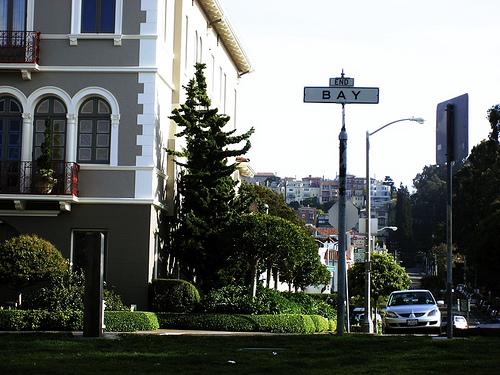How many motorcycles are parked in front of the home?
Write a very short answer. 0. How many people are in the street?
Quick response, please. 0. What material is the house in the background made of?
Concise answer only. Concrete. What is the season?
Short answer required. Summer. What does the sign say?
Concise answer only. Bay. Does this look like a high income property?
Be succinct. Yes. What color is the sign?
Quick response, please. White. How many clocks can be seen in the photo?
Keep it brief. 0. What kind of automobile is at the center of the photo?
Write a very short answer. Sedan. How many cars are visible on this street?
Concise answer only. 1. Is this a modern building?
Quick response, please. Yes. What color is the car?
Answer briefly. Silver. What is the top first letter printed on the pipe?
Write a very short answer. B. What color is the street name sign?
Short answer required. White. Is the car moving?
Give a very brief answer. No. What is the third letter in the street name?
Write a very short answer. Y. 